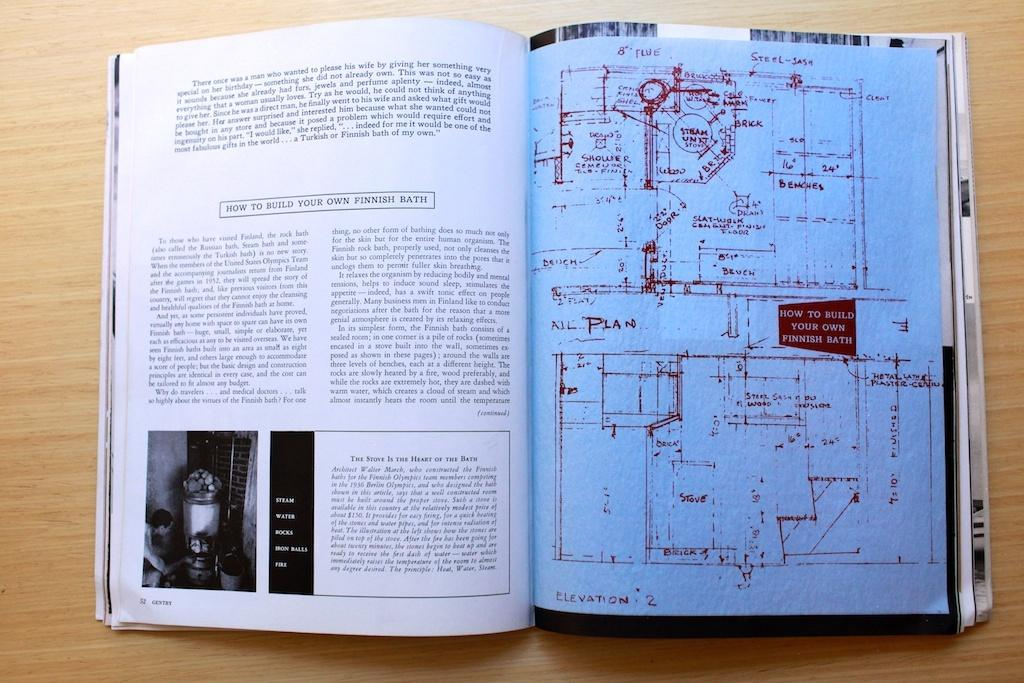<image>
Describe the image concisely. A book is opened to a page about hot to build your own Finnish bath. 